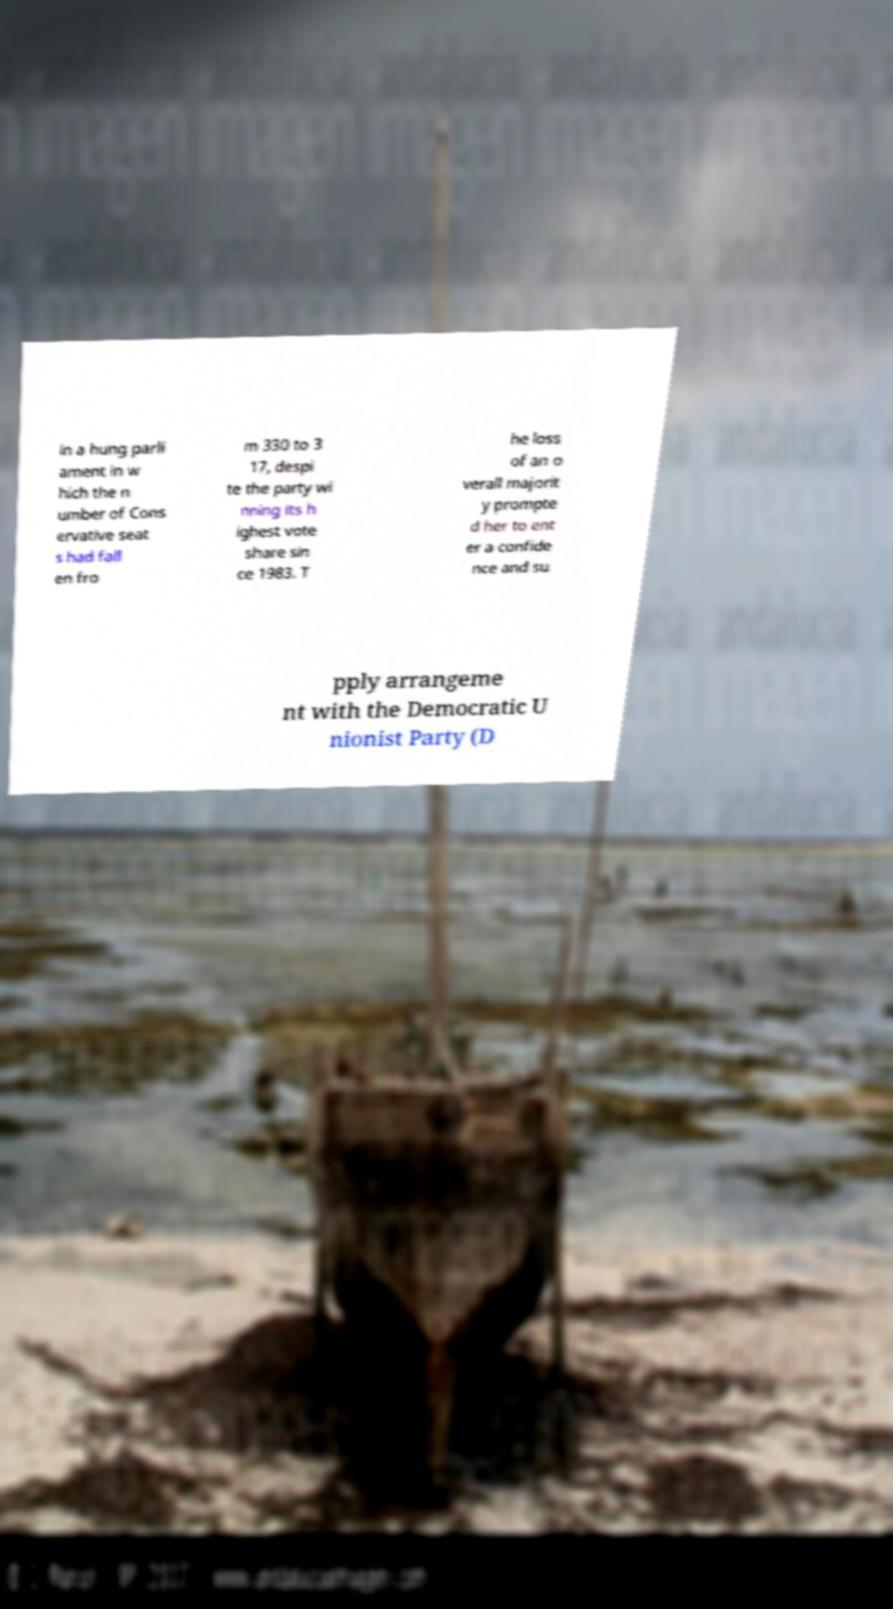Please identify and transcribe the text found in this image. in a hung parli ament in w hich the n umber of Cons ervative seat s had fall en fro m 330 to 3 17, despi te the party wi nning its h ighest vote share sin ce 1983. T he loss of an o verall majorit y prompte d her to ent er a confide nce and su pply arrangeme nt with the Democratic U nionist Party (D 